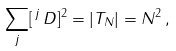Convert formula to latex. <formula><loc_0><loc_0><loc_500><loc_500>\sum _ { j } [ \, { ^ { j } } \, D ] ^ { 2 } = | T _ { N } | = N ^ { 2 } \, ,</formula> 